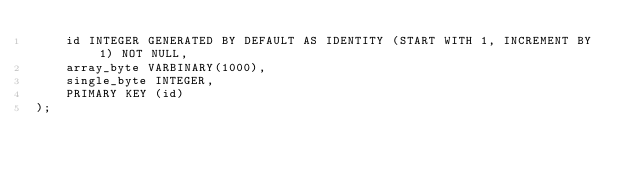<code> <loc_0><loc_0><loc_500><loc_500><_SQL_>    id INTEGER GENERATED BY DEFAULT AS IDENTITY (START WITH 1, INCREMENT BY 1) NOT NULL,
    array_byte VARBINARY(1000),
    single_byte INTEGER,
    PRIMARY KEY (id)
);</code> 